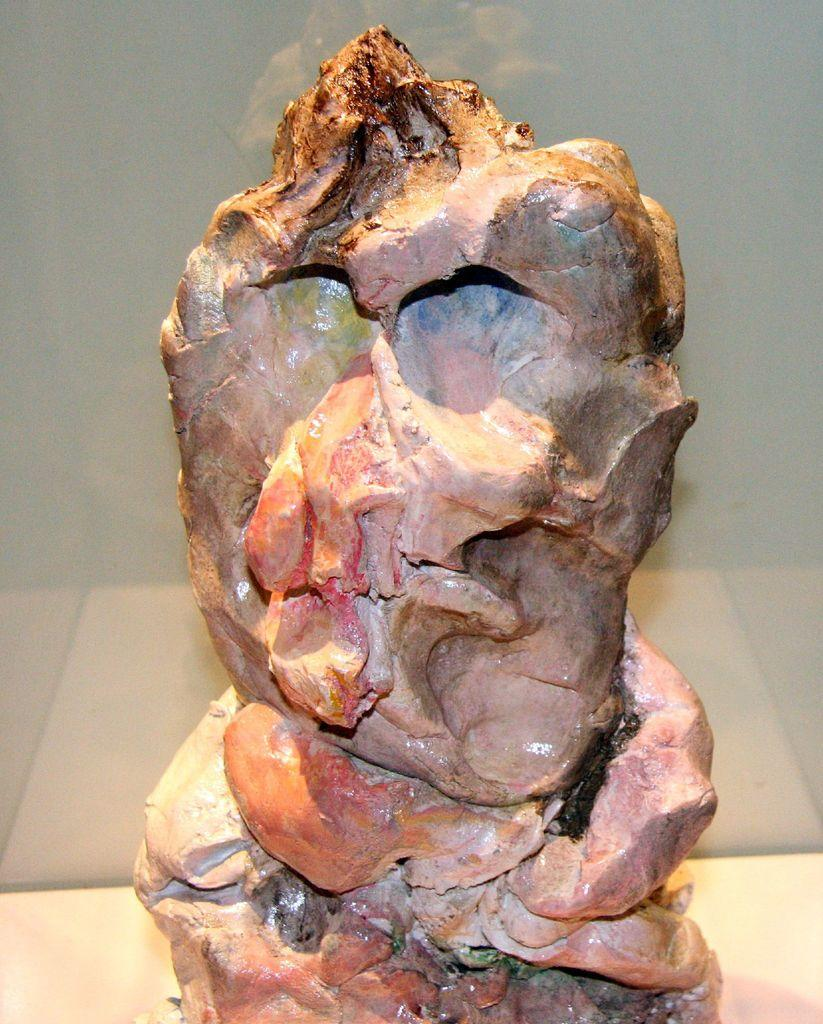What is the main subject of the image? The main subject of the image is an object that resembles a sculpture. Can you describe the background of the image? There is a wall visible behind the sculpture. What month is depicted in the sculpture? The sculpture does not depict a month; it is a sculpture-like object without any specific details related to a month. 